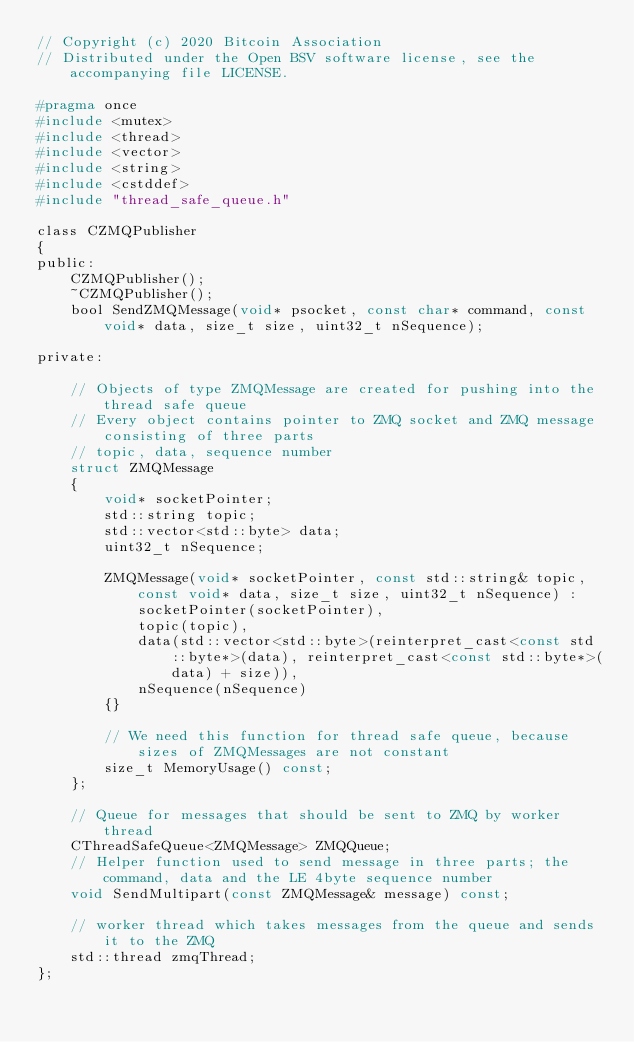<code> <loc_0><loc_0><loc_500><loc_500><_C_>// Copyright (c) 2020 Bitcoin Association
// Distributed under the Open BSV software license, see the accompanying file LICENSE.

#pragma once
#include <mutex>
#include <thread>
#include <vector>
#include <string>
#include <cstddef>
#include "thread_safe_queue.h"

class CZMQPublisher
{
public:
    CZMQPublisher();
    ~CZMQPublisher();
    bool SendZMQMessage(void* psocket, const char* command, const void* data, size_t size, uint32_t nSequence);

private:

    // Objects of type ZMQMessage are created for pushing into the thread safe queue
    // Every object contains pointer to ZMQ socket and ZMQ message consisting of three parts
    // topic, data, sequence number
    struct ZMQMessage
    {
        void* socketPointer;
        std::string topic;
        std::vector<std::byte> data;
        uint32_t nSequence;

        ZMQMessage(void* socketPointer, const std::string& topic,  const void* data, size_t size, uint32_t nSequence) : 
            socketPointer(socketPointer),
            topic(topic),
            data(std::vector<std::byte>(reinterpret_cast<const std::byte*>(data), reinterpret_cast<const std::byte*>(data) + size)),
            nSequence(nSequence)
        {}

        // We need this function for thread safe queue, because sizes of ZMQMessages are not constant
        size_t MemoryUsage() const;
    };

    // Queue for messages that should be sent to ZMQ by worker thread
    CThreadSafeQueue<ZMQMessage> ZMQQueue;
    // Helper function used to send message in three parts; the command, data and the LE 4byte sequence number
    void SendMultipart(const ZMQMessage& message) const;

    // worker thread which takes messages from the queue and sends it to the ZMQ
    std::thread zmqThread; 
};</code> 